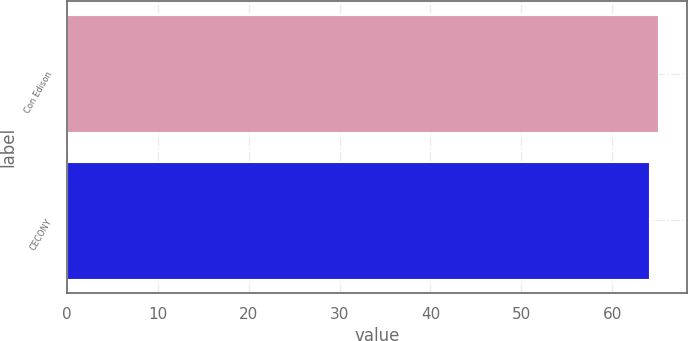Convert chart to OTSL. <chart><loc_0><loc_0><loc_500><loc_500><bar_chart><fcel>Con Edison<fcel>CECONY<nl><fcel>65<fcel>64<nl></chart> 